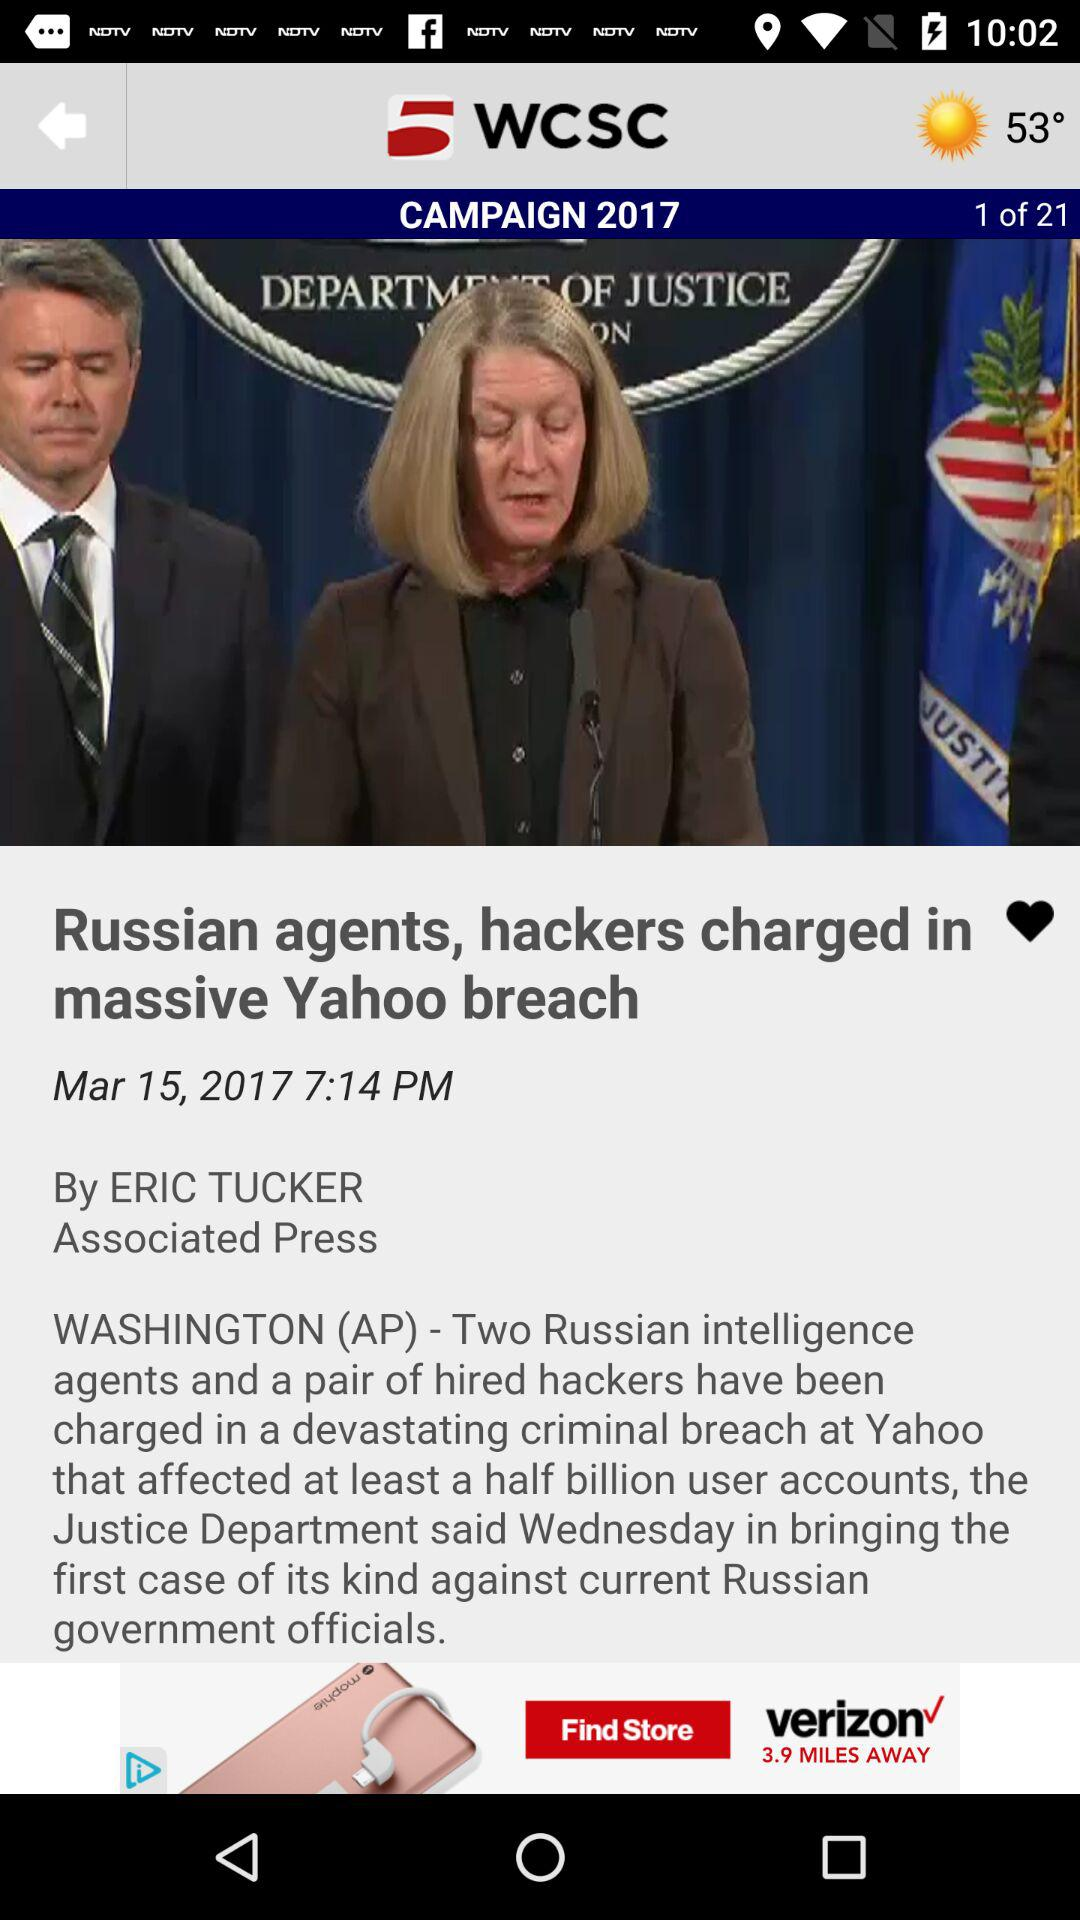When was the news "Russian agents, hackers charged in massive Yahoo breach" published? The news was published on March 15, 2017 at 7:14 PM. 